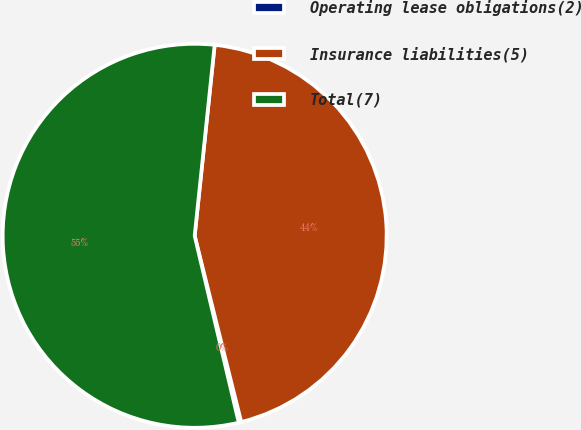<chart> <loc_0><loc_0><loc_500><loc_500><pie_chart><fcel>Operating lease obligations(2)<fcel>Insurance liabilities(5)<fcel>Total(7)<nl><fcel>0.21%<fcel>44.44%<fcel>55.35%<nl></chart> 